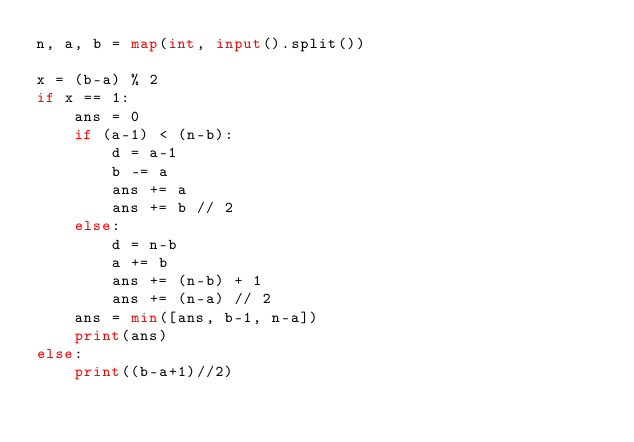Convert code to text. <code><loc_0><loc_0><loc_500><loc_500><_Python_>n, a, b = map(int, input().split())

x = (b-a) % 2
if x == 1:
    ans = 0
    if (a-1) < (n-b):
        d = a-1
        b -= a
        ans += a
        ans += b // 2
    else:
        d = n-b
        a += b
        ans += (n-b) + 1
        ans += (n-a) // 2
    ans = min([ans, b-1, n-a])
    print(ans)
else:
    print((b-a+1)//2)
</code> 